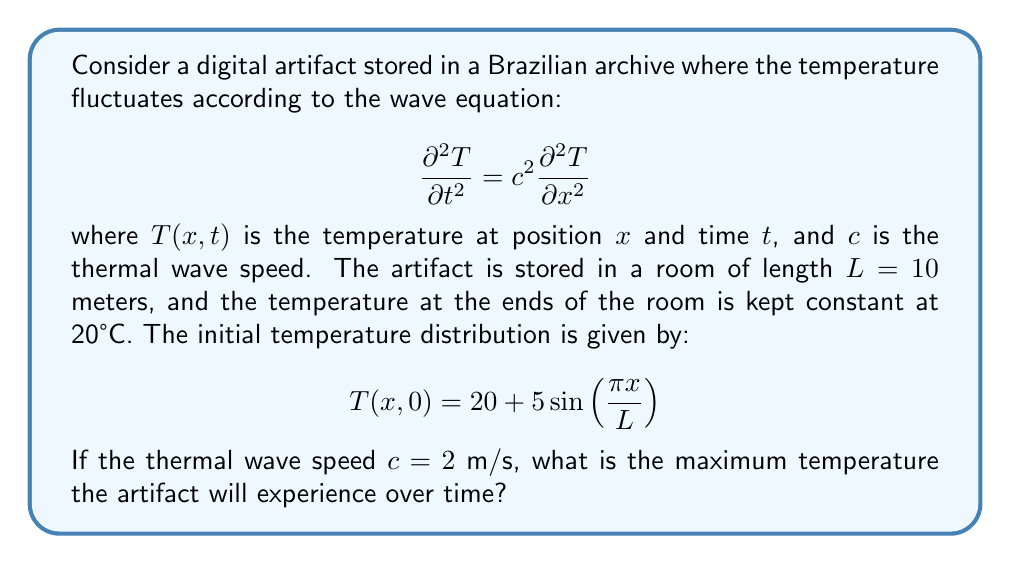Can you solve this math problem? To solve this problem, we need to follow these steps:

1) First, we recognize that this is a wave equation problem with fixed boundary conditions (Dirichlet boundary conditions) and a given initial condition.

2) The general solution for this type of problem is given by:

   $$T(x,t) = \sum_{n=1}^{\infty} (A_n \cos(\omega_n t) + B_n \sin(\omega_n t)) \sin(\frac{n\pi x}{L})$$

   where $\omega_n = \frac{n\pi c}{L}$

3) Given the initial condition, we can see that only the first term (n=1) of the series is non-zero, and it matches the sine term. So, our solution simplifies to:

   $$T(x,t) = 20 + 5\cos(\omega_1 t) \sin(\frac{\pi x}{L})$$

4) We need to calculate $\omega_1$:

   $$\omega_1 = \frac{\pi c}{L} = \frac{\pi \cdot 2}{10} = \frac{\pi}{5}$$

5) So our final solution is:

   $$T(x,t) = 20 + 5\cos(\frac{\pi t}{5}) \sin(\frac{\pi x}{10})$$

6) To find the maximum temperature, we need to maximize both cosine and sine terms:
   - $\cos(\frac{\pi t}{5})$ has a maximum value of 1
   - $\sin(\frac{\pi x}{10})$ has a maximum value of 1

7) Therefore, the maximum temperature is:

   $$T_{max} = 20 + 5 \cdot 1 \cdot 1 = 25$$
Answer: 25°C 